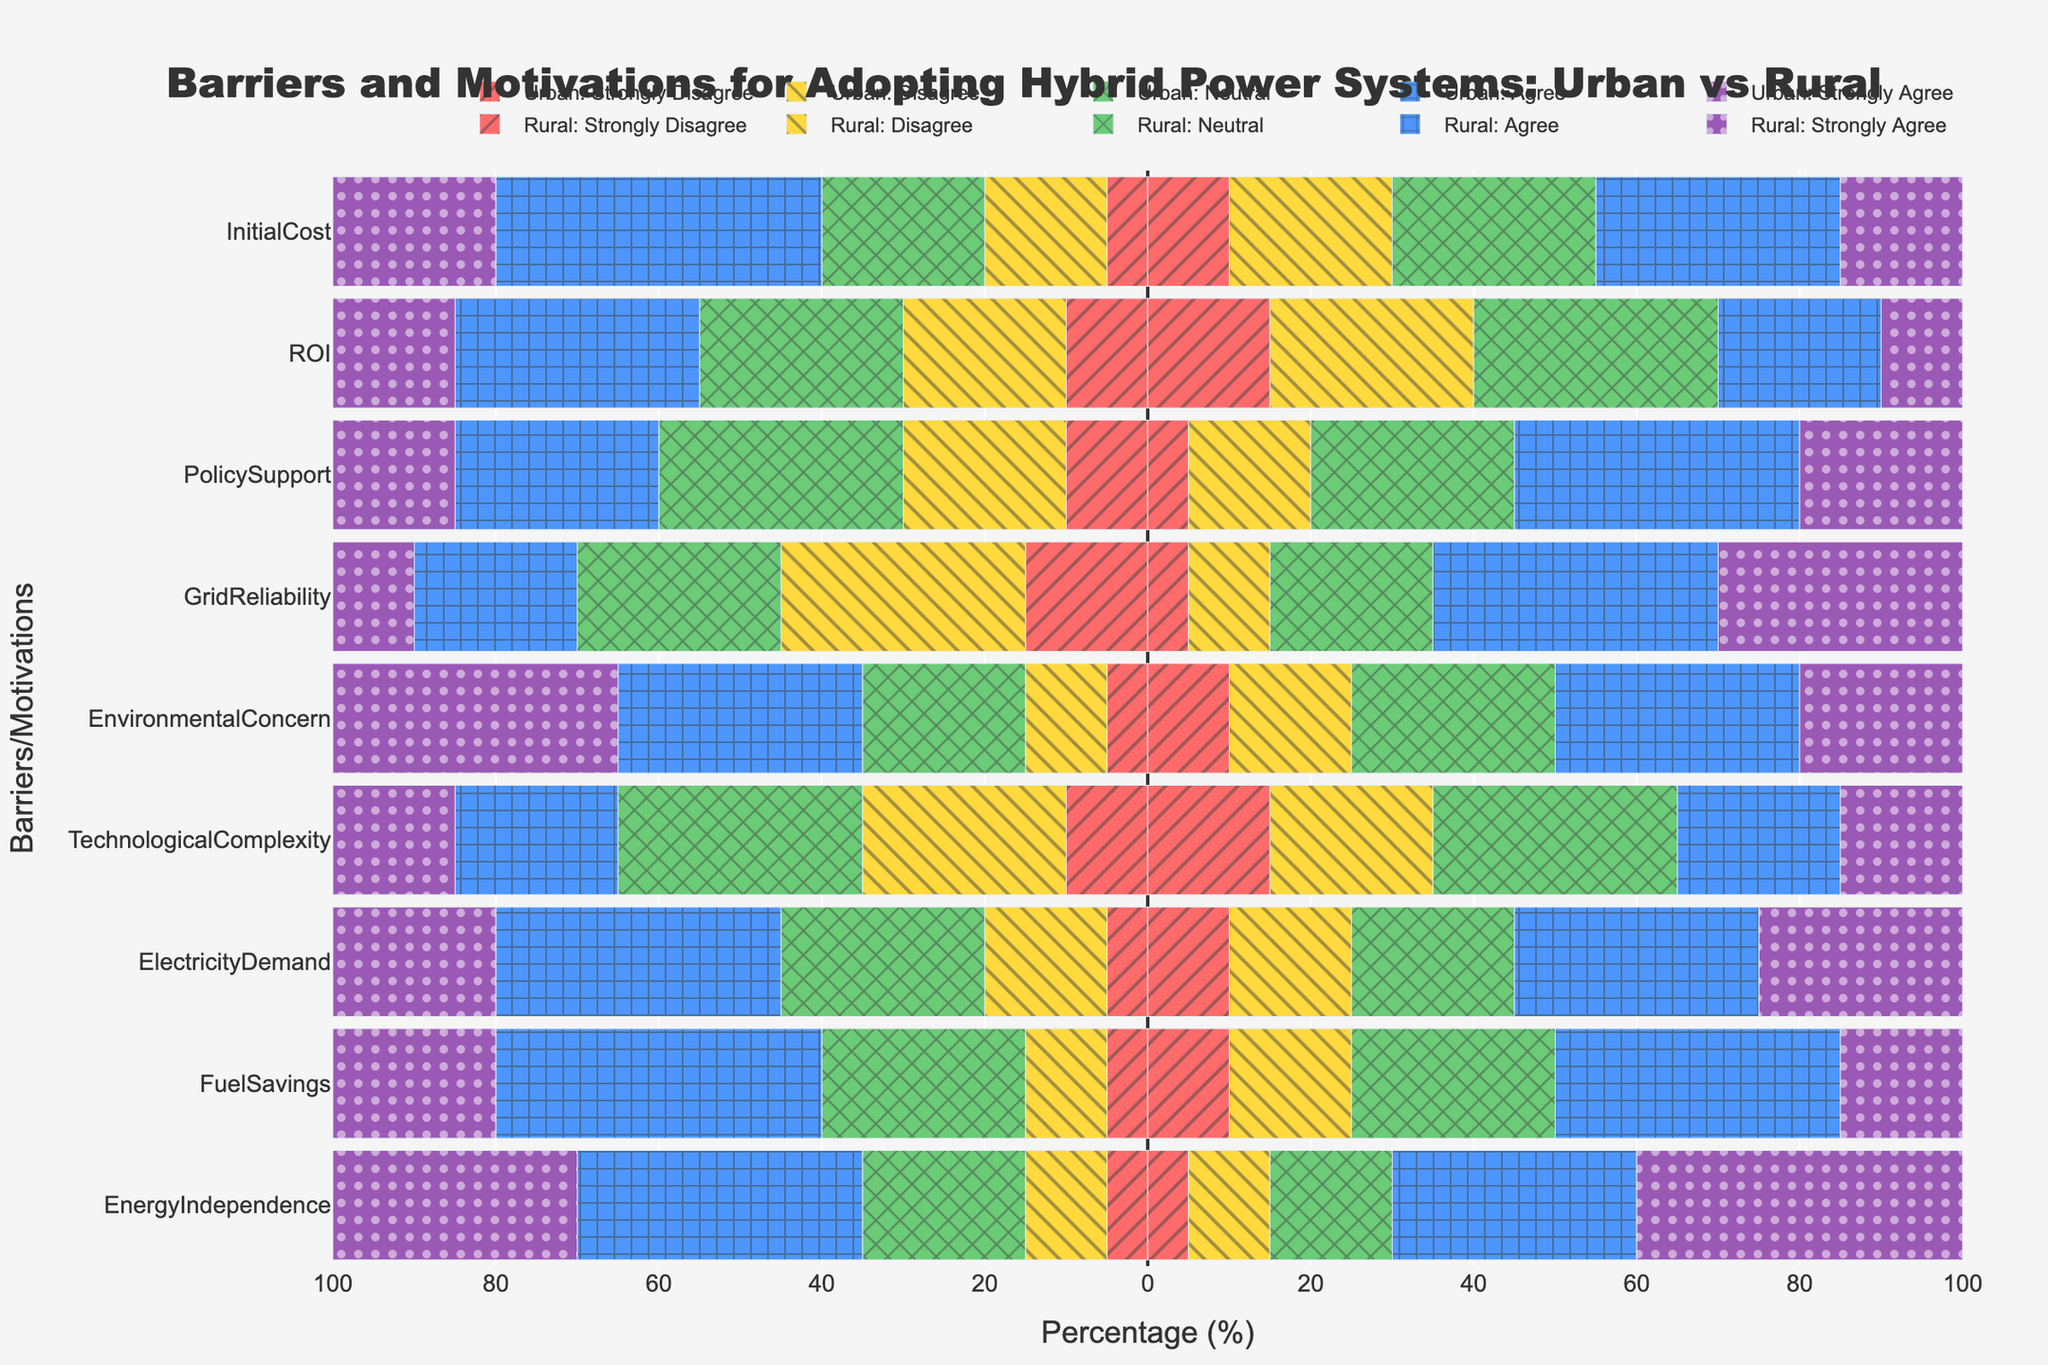What is the most common barrier for businesses in rural areas? To find the most common barrier in rural areas, observe the longest bar on the right-hand side of the chart. The "GridReliability" category has the highest agreement percentage.
Answer: GridReliability How does the motivation for "EnvironmentalConcern" compare between urban and rural areas? Compare the shades of green and purple bars for "EnvironmentalConcern" on both sides. In urban areas, 65% agree or strongly agree, while in rural areas, it's 50%. Therefore, urban areas show a higher motivation.
Answer: Higher in urban areas Which category has the largest difference in "Strongly Agree" responses between urban and rural areas? Compare the lengths of the "Strongly Agree" bars for both urban and rural areas across all categories. "EnergyIndependence" has a 10% higher response in rural areas (40% vs. 30%).
Answer: EnergyIndependence What is the sum of "Disagree" responses for "InitialCost" and "TechnologicalComplexity" in rural areas? Check the "Disagree" percentages for both categories in rural areas and sum them up: InitialCost (20%), TechnologicalComplexity (20%). Therefore, the sum is 20% + 20% = 40%.
Answer: 40% In which category do urban areas express the most "Neutral" sentiment? Look for the category with the longest "Neutral" bar on the left-hand side. "TechnologicalComplexity" has the highest "Neutral" percentage in urban areas at 30%.
Answer: TechnologicalComplexity Which barrier or motivation has nearly equal "Neutral" responses in both urban and rural areas? Compare the lengths of the "Neutral" bars for both urban and rural areas across all categories. "TechnologicalComplexity" has similar values with 30% in urban and 30% in rural.
Answer: TechnologicalComplexity What percentage of urban respondents strongly disagree with "InitialCost" and "GridReliability" combined? Check the "Strongly Disagree" responses for both categories in urban areas and sum them: InitialCost (5%) + GridReliability (15%). Therefore, the total is 5% + 15% = 20%.
Answer: 20% Is there a barrier or motivation where rural "Agree" responses exceed urban "Agree" responses by more than 10%? Compare the "Agree" responses across all categories. In "GridReliability," rural responses (35%) exceed urban (20%) by 15%.
Answer: GridReliability Are urban areas more concerned about the "InitialCost" of adopting hybrid power systems compared to rural areas? Observe the sum of "Agree" and "Strongly Agree" bars for "InitialCost." Urban agreement (40% + 20% = 60%) is higher than rural agreement (30% + 15% = 45%). Consequently, urban areas show more concern.
Answer: Yes Comparing "PolicySupport" in rural and urban areas, which has more combined agreement (Agree + Strongly Agree) responses? Sum the "Agree" and "Strongly Agree" responses for "PolicySupport" in both areas. Urban responses: 25% + 15% = 40%, Rural responses: 35% + 20% = 55%. Rural areas have more combined agreement responses.
Answer: Rural areas 